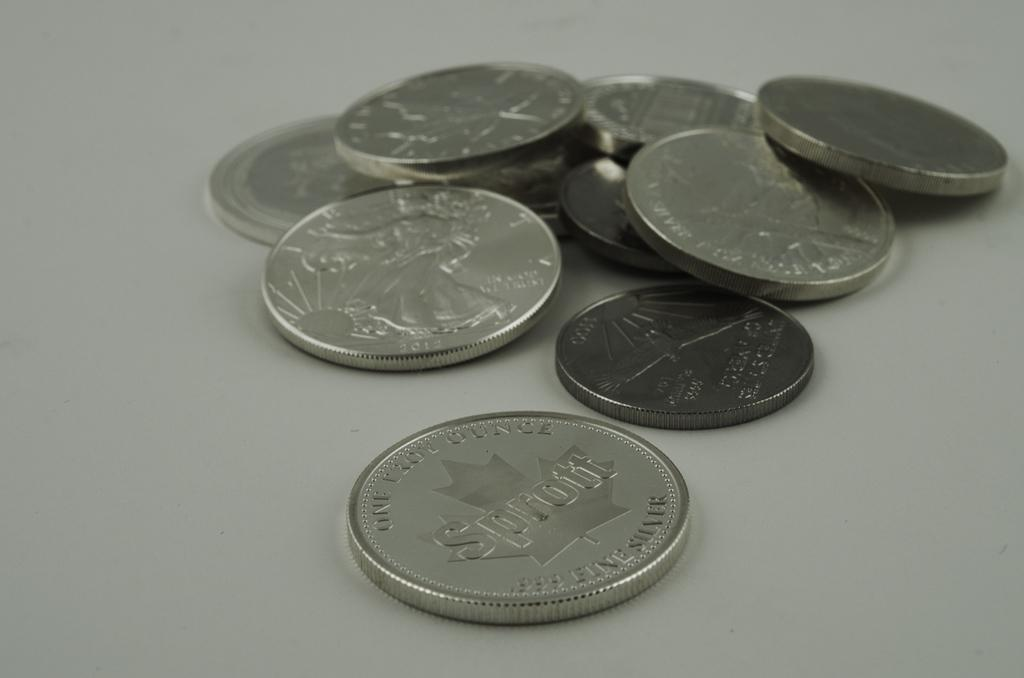<image>
Relay a brief, clear account of the picture shown. Several coins with one of them having the word Sprott on it 